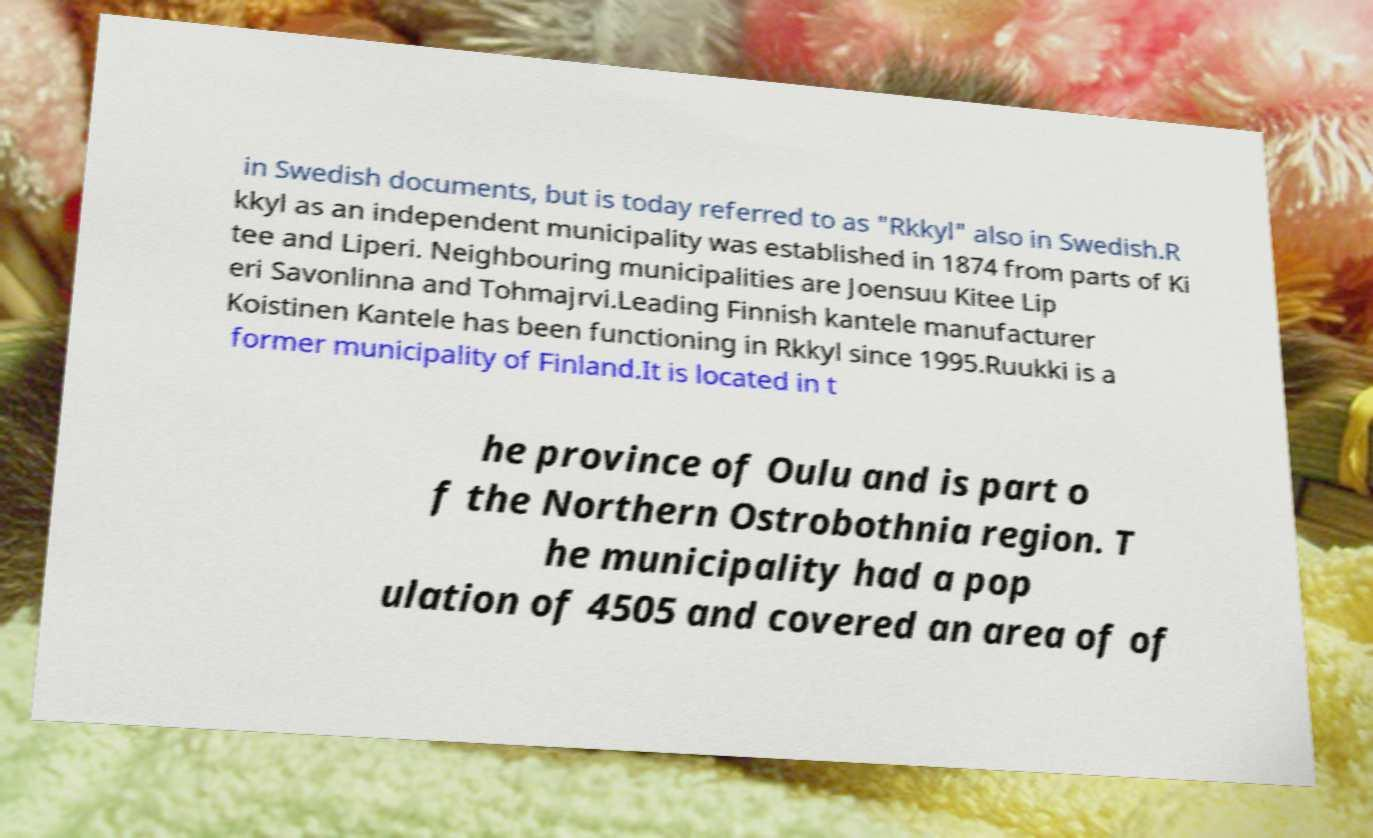I need the written content from this picture converted into text. Can you do that? in Swedish documents, but is today referred to as "Rkkyl" also in Swedish.R kkyl as an independent municipality was established in 1874 from parts of Ki tee and Liperi. Neighbouring municipalities are Joensuu Kitee Lip eri Savonlinna and Tohmajrvi.Leading Finnish kantele manufacturer Koistinen Kantele has been functioning in Rkkyl since 1995.Ruukki is a former municipality of Finland.It is located in t he province of Oulu and is part o f the Northern Ostrobothnia region. T he municipality had a pop ulation of 4505 and covered an area of of 